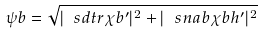<formula> <loc_0><loc_0><loc_500><loc_500>\psi b = \sqrt { | \ s d t r \chi b ^ { \prime } | ^ { 2 } + | \ s n a b \chi b h ^ { \prime } | ^ { 2 } }</formula> 